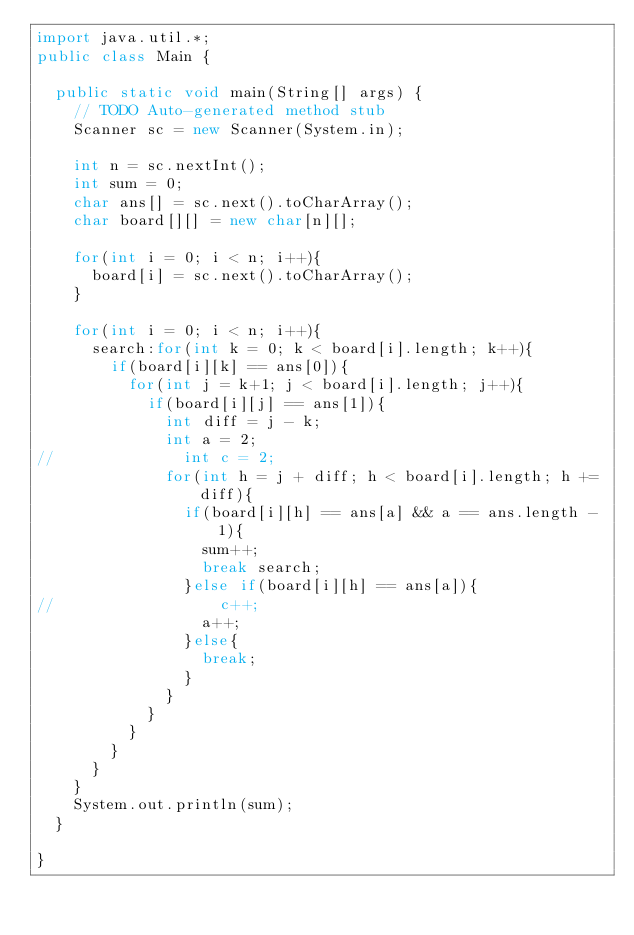Convert code to text. <code><loc_0><loc_0><loc_500><loc_500><_Java_>import java.util.*;
public class Main {

	public static void main(String[] args) {
		// TODO Auto-generated method stub
		Scanner sc = new Scanner(System.in);
		
		int n = sc.nextInt();
		int sum = 0;
		char ans[] = sc.next().toCharArray();		
		char board[][] = new char[n][];
		
		for(int i = 0; i < n; i++){
			board[i] = sc.next().toCharArray();
		}
		
		for(int i = 0; i < n; i++){
			search:for(int k = 0; k < board[i].length; k++){
				if(board[i][k] == ans[0]){
					for(int j = k+1; j < board[i].length; j++){
						if(board[i][j] == ans[1]){
							int diff = j - k;
							int a = 2;
//							int c = 2;
							for(int h = j + diff; h < board[i].length; h += diff){
								if(board[i][h] == ans[a] && a == ans.length - 1){
									sum++;
									break search;
								}else if(board[i][h] == ans[a]){
//									c++;
									a++;
								}else{
									break;
								}
							}
						}
					}
				}
			}
		}
		System.out.println(sum);
	}

}</code> 